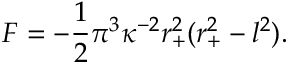Convert formula to latex. <formula><loc_0><loc_0><loc_500><loc_500>F = - \frac { 1 } { 2 } \pi ^ { 3 } \kappa ^ { - 2 } r _ { + } ^ { 2 } ( r _ { + } ^ { 2 } - l ^ { 2 } ) .</formula> 